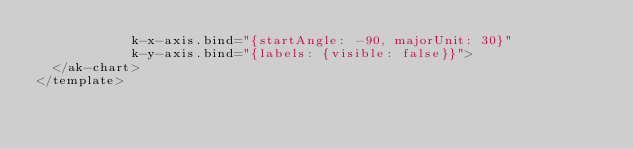<code> <loc_0><loc_0><loc_500><loc_500><_HTML_>            k-x-axis.bind="{startAngle: -90, majorUnit: 30}"
            k-y-axis.bind="{labels: {visible: false}}">
  </ak-chart>
</template>
</code> 